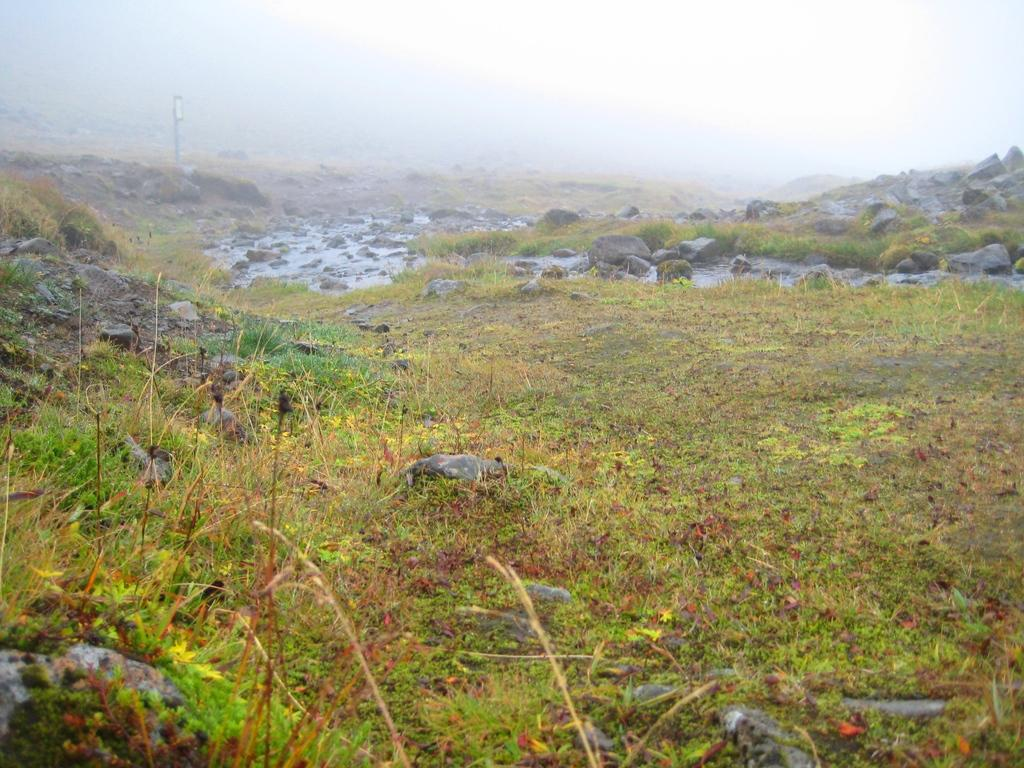What type of natural elements can be seen in the image? There are rocks, plants, and grass visible in the image. Is there any water present in the image? Yes, there is water visible in the image. What can be seen in the background of the image? The sky is visible in the background of the image. What time of day is it in the image, and how does the haircut of the person in the image look? The time of day cannot be determined from the image, and there is no person present to have a haircut. 